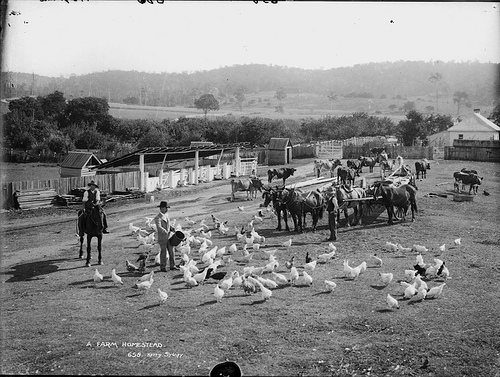Can you speculate on the time period or era this image might be from? The attire of the people, the horse-drawn carts, and the absence of modern vehicles or machinery suggest this photograph was taken in the late 19th or early 20th century, a time before widespread mechanization in farming. 